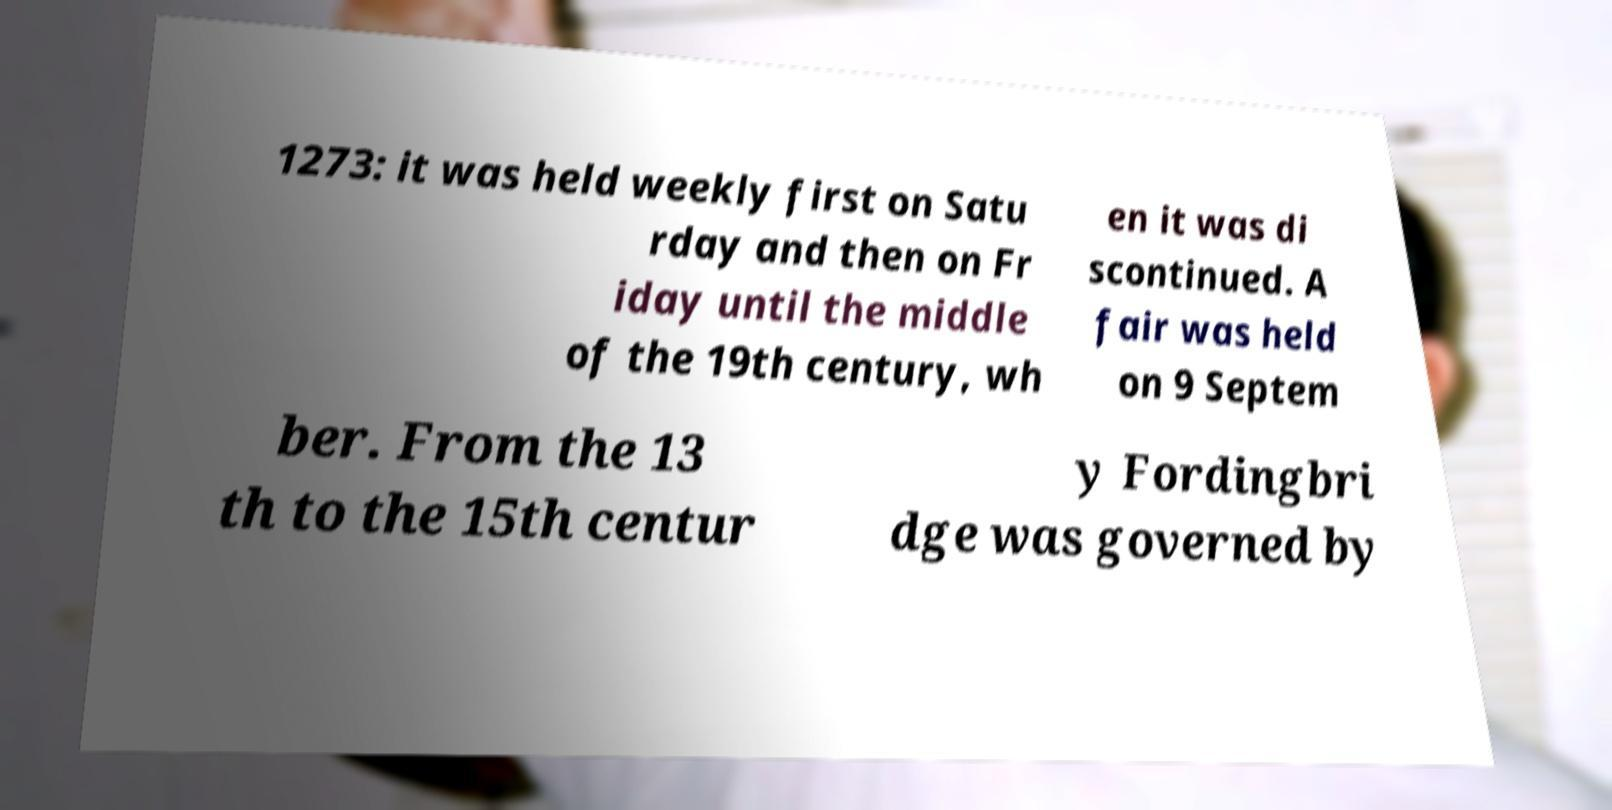Could you assist in decoding the text presented in this image and type it out clearly? 1273: it was held weekly first on Satu rday and then on Fr iday until the middle of the 19th century, wh en it was di scontinued. A fair was held on 9 Septem ber. From the 13 th to the 15th centur y Fordingbri dge was governed by 